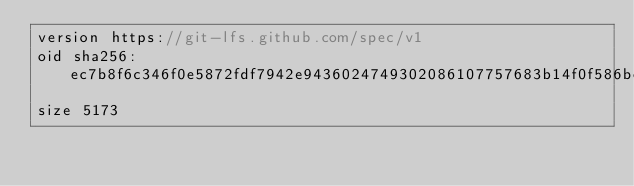<code> <loc_0><loc_0><loc_500><loc_500><_C++_>version https://git-lfs.github.com/spec/v1
oid sha256:ec7b8f6c346f0e5872fdf7942e9436024749302086107757683b14f0f586bccc
size 5173
</code> 